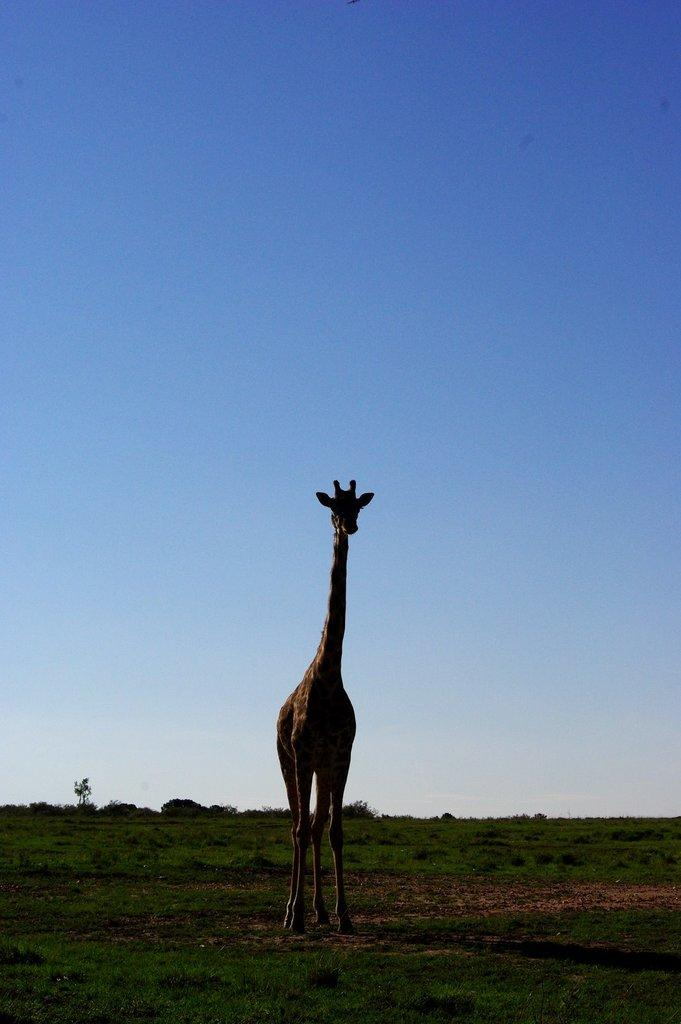What animal is present in the image? There is a giraffe in the image. What is the giraffe's position in the image? The giraffe is standing on the ground. What type of vegetation can be seen in the image? There is grass visible in the image. What else can be seen in the image besides the giraffe and grass? There are trees in the image. What is visible in the background of the image? The sky is visible in the background of the image. What time of day is indicated by the hour on the clock in the image? There is no clock present in the image, so it is not possible to determine the time of day. 